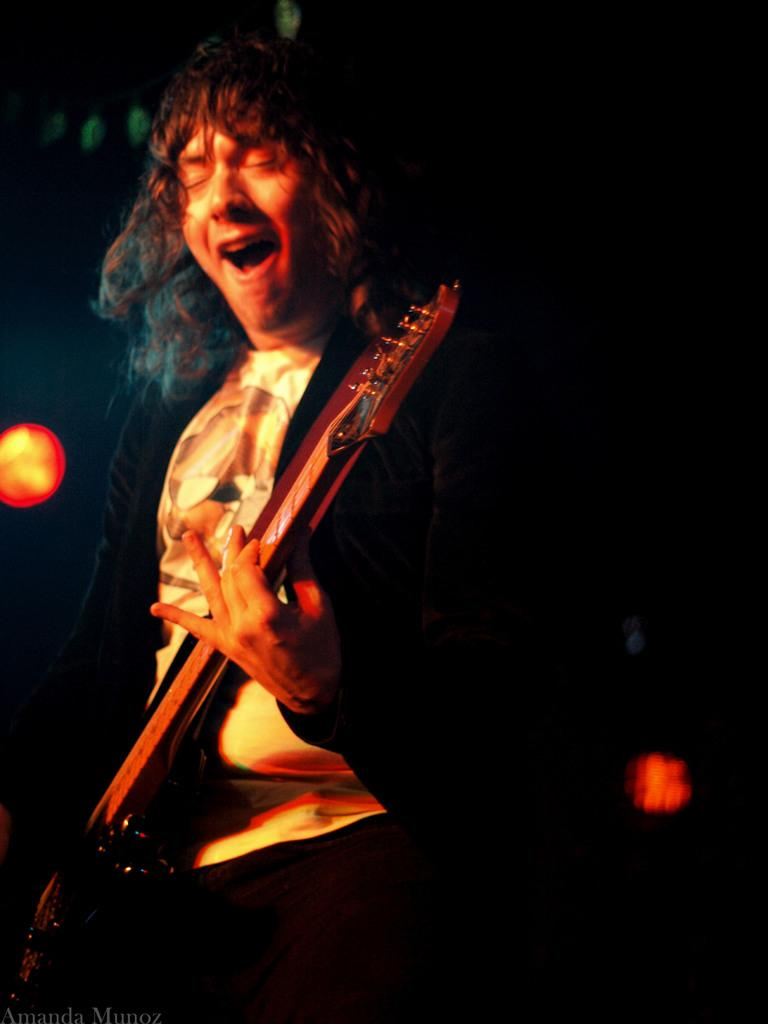What is the man in the image doing? The man is playing a guitar in the image. What object is the man using to create music? The man is using a guitar to create music. Can you describe the lighting in the image? There is light in the image. Where is the store located in the image? There is no store present in the image. What type of crown is the man wearing in the image? The man is not wearing a crown in the image. 